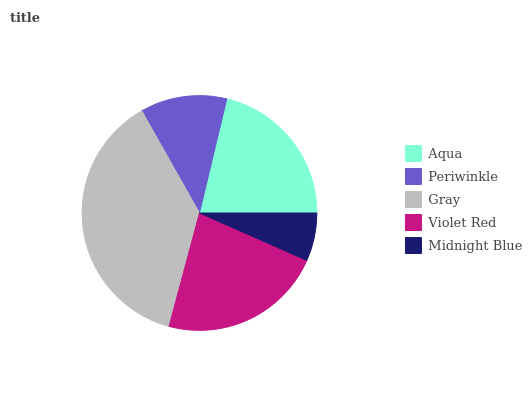Is Midnight Blue the minimum?
Answer yes or no. Yes. Is Gray the maximum?
Answer yes or no. Yes. Is Periwinkle the minimum?
Answer yes or no. No. Is Periwinkle the maximum?
Answer yes or no. No. Is Aqua greater than Periwinkle?
Answer yes or no. Yes. Is Periwinkle less than Aqua?
Answer yes or no. Yes. Is Periwinkle greater than Aqua?
Answer yes or no. No. Is Aqua less than Periwinkle?
Answer yes or no. No. Is Aqua the high median?
Answer yes or no. Yes. Is Aqua the low median?
Answer yes or no. Yes. Is Periwinkle the high median?
Answer yes or no. No. Is Periwinkle the low median?
Answer yes or no. No. 